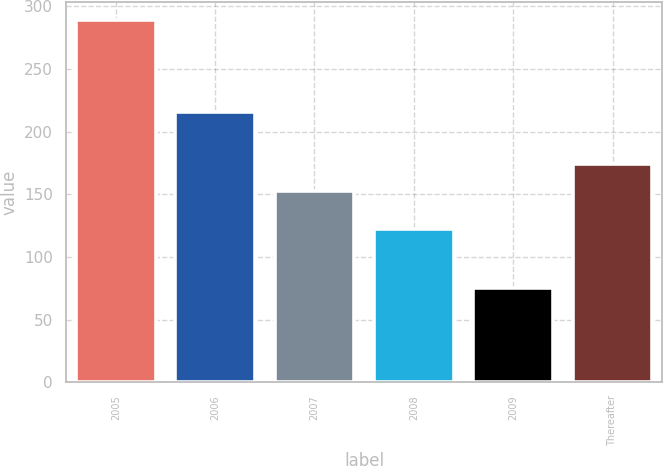Convert chart to OTSL. <chart><loc_0><loc_0><loc_500><loc_500><bar_chart><fcel>2005<fcel>2006<fcel>2007<fcel>2008<fcel>2009<fcel>Thereafter<nl><fcel>289<fcel>216<fcel>153<fcel>122<fcel>75<fcel>174.4<nl></chart> 